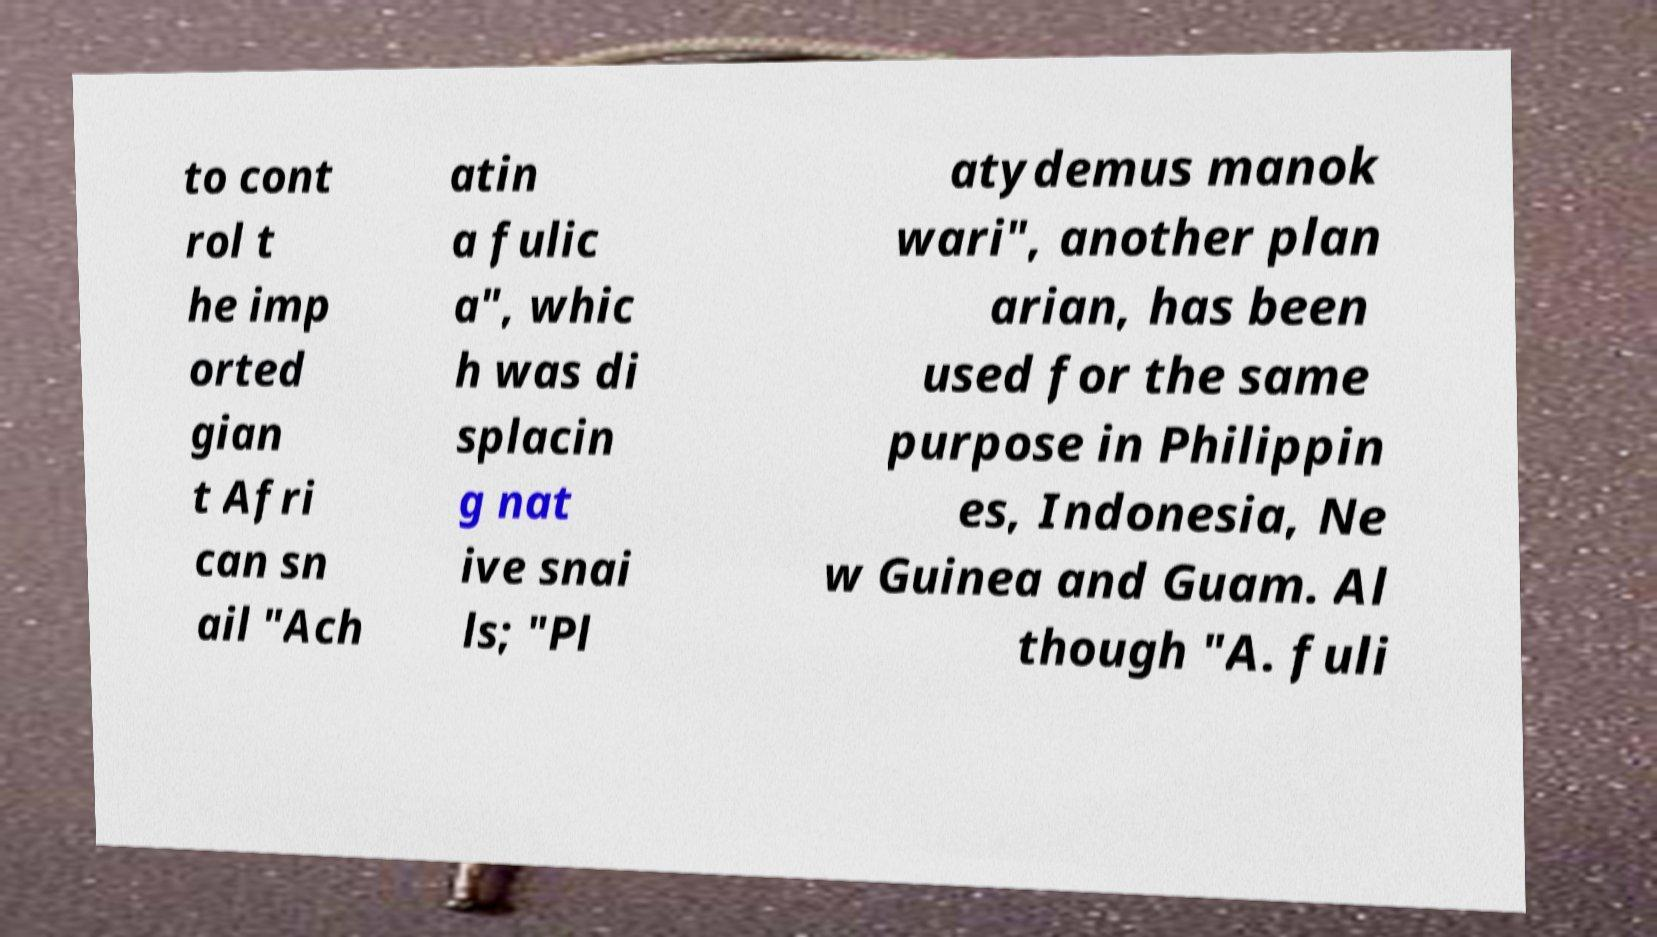What messages or text are displayed in this image? I need them in a readable, typed format. to cont rol t he imp orted gian t Afri can sn ail "Ach atin a fulic a", whic h was di splacin g nat ive snai ls; "Pl atydemus manok wari", another plan arian, has been used for the same purpose in Philippin es, Indonesia, Ne w Guinea and Guam. Al though "A. fuli 